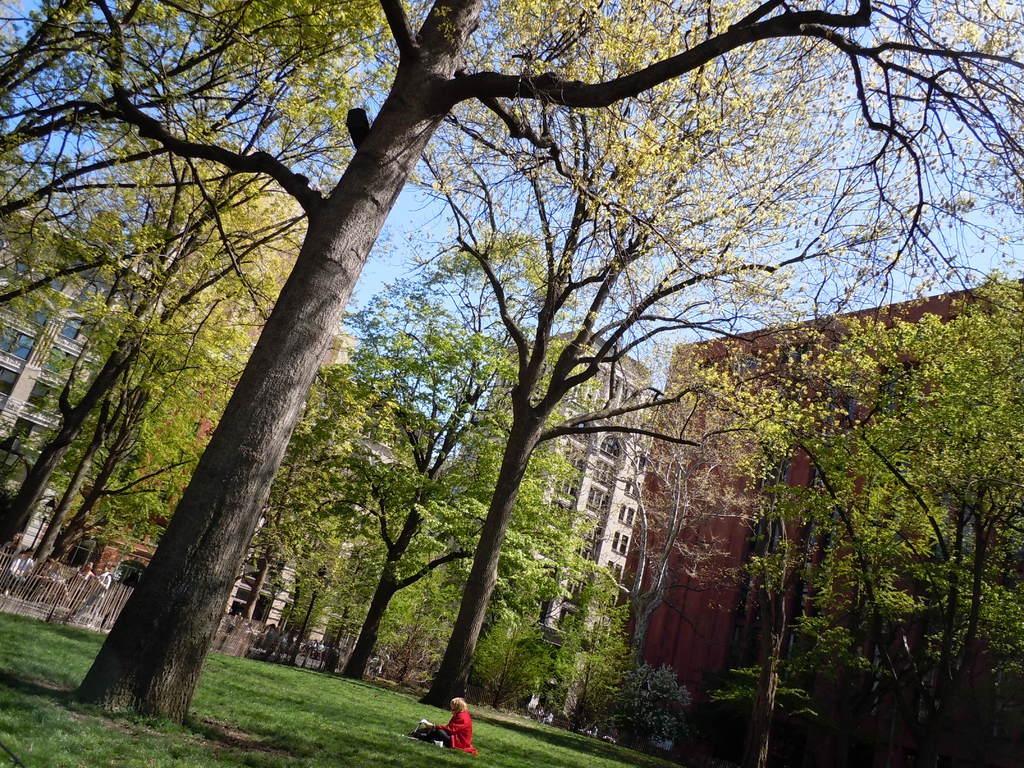Can you describe this image briefly? In this image we can see one person sitting. And we can see the grass, plants and tree trunks. And we can see the buildings, metal fence. And we can see a few people in front of the building. And we can see the sky. 